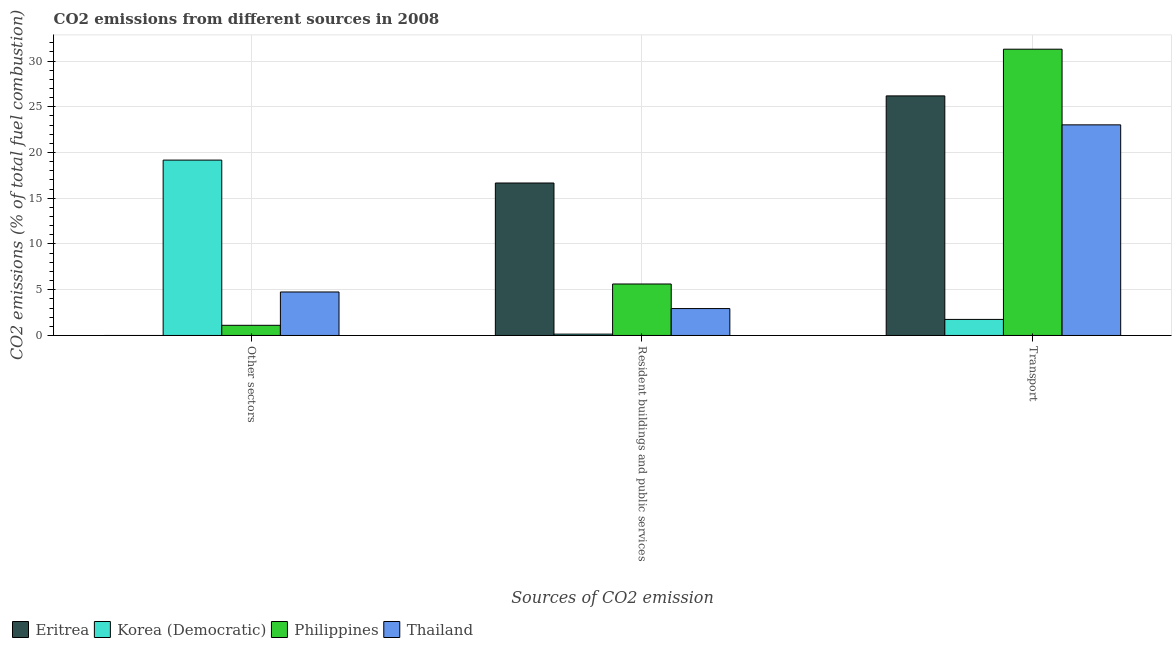How many different coloured bars are there?
Make the answer very short. 4. How many groups of bars are there?
Keep it short and to the point. 3. Are the number of bars per tick equal to the number of legend labels?
Provide a short and direct response. No. How many bars are there on the 1st tick from the right?
Your answer should be very brief. 4. What is the label of the 1st group of bars from the left?
Offer a very short reply. Other sectors. What is the percentage of co2 emissions from other sectors in Philippines?
Your answer should be compact. 1.11. Across all countries, what is the maximum percentage of co2 emissions from other sectors?
Offer a terse response. 19.17. Across all countries, what is the minimum percentage of co2 emissions from resident buildings and public services?
Provide a succinct answer. 0.15. In which country was the percentage of co2 emissions from resident buildings and public services maximum?
Your answer should be compact. Eritrea. What is the total percentage of co2 emissions from transport in the graph?
Your answer should be compact. 82.27. What is the difference between the percentage of co2 emissions from resident buildings and public services in Eritrea and that in Thailand?
Provide a succinct answer. 13.73. What is the difference between the percentage of co2 emissions from other sectors in Korea (Democratic) and the percentage of co2 emissions from resident buildings and public services in Eritrea?
Your response must be concise. 2.5. What is the average percentage of co2 emissions from transport per country?
Provide a short and direct response. 20.57. What is the difference between the percentage of co2 emissions from resident buildings and public services and percentage of co2 emissions from transport in Philippines?
Give a very brief answer. -25.67. What is the ratio of the percentage of co2 emissions from transport in Thailand to that in Philippines?
Provide a short and direct response. 0.74. Is the difference between the percentage of co2 emissions from resident buildings and public services in Philippines and Thailand greater than the difference between the percentage of co2 emissions from other sectors in Philippines and Thailand?
Offer a very short reply. Yes. What is the difference between the highest and the second highest percentage of co2 emissions from resident buildings and public services?
Make the answer very short. 11.04. What is the difference between the highest and the lowest percentage of co2 emissions from resident buildings and public services?
Your response must be concise. 16.52. In how many countries, is the percentage of co2 emissions from resident buildings and public services greater than the average percentage of co2 emissions from resident buildings and public services taken over all countries?
Your answer should be very brief. 1. Is the sum of the percentage of co2 emissions from resident buildings and public services in Philippines and Thailand greater than the maximum percentage of co2 emissions from transport across all countries?
Provide a succinct answer. No. Are all the bars in the graph horizontal?
Provide a succinct answer. No. How many countries are there in the graph?
Your response must be concise. 4. Does the graph contain any zero values?
Ensure brevity in your answer.  Yes. How are the legend labels stacked?
Offer a terse response. Horizontal. What is the title of the graph?
Make the answer very short. CO2 emissions from different sources in 2008. What is the label or title of the X-axis?
Your answer should be very brief. Sources of CO2 emission. What is the label or title of the Y-axis?
Offer a terse response. CO2 emissions (% of total fuel combustion). What is the CO2 emissions (% of total fuel combustion) of Korea (Democratic) in Other sectors?
Offer a very short reply. 19.17. What is the CO2 emissions (% of total fuel combustion) in Philippines in Other sectors?
Your answer should be very brief. 1.11. What is the CO2 emissions (% of total fuel combustion) in Thailand in Other sectors?
Offer a very short reply. 4.75. What is the CO2 emissions (% of total fuel combustion) in Eritrea in Resident buildings and public services?
Give a very brief answer. 16.67. What is the CO2 emissions (% of total fuel combustion) in Korea (Democratic) in Resident buildings and public services?
Offer a very short reply. 0.15. What is the CO2 emissions (% of total fuel combustion) of Philippines in Resident buildings and public services?
Offer a very short reply. 5.63. What is the CO2 emissions (% of total fuel combustion) of Thailand in Resident buildings and public services?
Offer a very short reply. 2.94. What is the CO2 emissions (% of total fuel combustion) of Eritrea in Transport?
Your answer should be very brief. 26.19. What is the CO2 emissions (% of total fuel combustion) of Korea (Democratic) in Transport?
Your answer should be compact. 1.75. What is the CO2 emissions (% of total fuel combustion) of Philippines in Transport?
Offer a terse response. 31.3. What is the CO2 emissions (% of total fuel combustion) of Thailand in Transport?
Provide a short and direct response. 23.02. Across all Sources of CO2 emission, what is the maximum CO2 emissions (% of total fuel combustion) of Eritrea?
Your answer should be compact. 26.19. Across all Sources of CO2 emission, what is the maximum CO2 emissions (% of total fuel combustion) of Korea (Democratic)?
Give a very brief answer. 19.17. Across all Sources of CO2 emission, what is the maximum CO2 emissions (% of total fuel combustion) in Philippines?
Offer a terse response. 31.3. Across all Sources of CO2 emission, what is the maximum CO2 emissions (% of total fuel combustion) of Thailand?
Keep it short and to the point. 23.02. Across all Sources of CO2 emission, what is the minimum CO2 emissions (% of total fuel combustion) of Korea (Democratic)?
Make the answer very short. 0.15. Across all Sources of CO2 emission, what is the minimum CO2 emissions (% of total fuel combustion) of Philippines?
Ensure brevity in your answer.  1.11. Across all Sources of CO2 emission, what is the minimum CO2 emissions (% of total fuel combustion) in Thailand?
Keep it short and to the point. 2.94. What is the total CO2 emissions (% of total fuel combustion) of Eritrea in the graph?
Your answer should be very brief. 42.86. What is the total CO2 emissions (% of total fuel combustion) in Korea (Democratic) in the graph?
Your response must be concise. 21.07. What is the total CO2 emissions (% of total fuel combustion) in Philippines in the graph?
Offer a terse response. 38.03. What is the total CO2 emissions (% of total fuel combustion) in Thailand in the graph?
Offer a terse response. 30.72. What is the difference between the CO2 emissions (% of total fuel combustion) of Korea (Democratic) in Other sectors and that in Resident buildings and public services?
Give a very brief answer. 19.03. What is the difference between the CO2 emissions (% of total fuel combustion) in Philippines in Other sectors and that in Resident buildings and public services?
Provide a short and direct response. -4.52. What is the difference between the CO2 emissions (% of total fuel combustion) in Thailand in Other sectors and that in Resident buildings and public services?
Ensure brevity in your answer.  1.81. What is the difference between the CO2 emissions (% of total fuel combustion) in Korea (Democratic) in Other sectors and that in Transport?
Your response must be concise. 17.42. What is the difference between the CO2 emissions (% of total fuel combustion) in Philippines in Other sectors and that in Transport?
Keep it short and to the point. -30.19. What is the difference between the CO2 emissions (% of total fuel combustion) in Thailand in Other sectors and that in Transport?
Your response must be concise. -18.27. What is the difference between the CO2 emissions (% of total fuel combustion) in Eritrea in Resident buildings and public services and that in Transport?
Offer a very short reply. -9.52. What is the difference between the CO2 emissions (% of total fuel combustion) in Korea (Democratic) in Resident buildings and public services and that in Transport?
Provide a short and direct response. -1.61. What is the difference between the CO2 emissions (% of total fuel combustion) in Philippines in Resident buildings and public services and that in Transport?
Offer a terse response. -25.67. What is the difference between the CO2 emissions (% of total fuel combustion) of Thailand in Resident buildings and public services and that in Transport?
Provide a short and direct response. -20.08. What is the difference between the CO2 emissions (% of total fuel combustion) in Korea (Democratic) in Other sectors and the CO2 emissions (% of total fuel combustion) in Philippines in Resident buildings and public services?
Ensure brevity in your answer.  13.54. What is the difference between the CO2 emissions (% of total fuel combustion) of Korea (Democratic) in Other sectors and the CO2 emissions (% of total fuel combustion) of Thailand in Resident buildings and public services?
Your response must be concise. 16.23. What is the difference between the CO2 emissions (% of total fuel combustion) of Philippines in Other sectors and the CO2 emissions (% of total fuel combustion) of Thailand in Resident buildings and public services?
Make the answer very short. -1.83. What is the difference between the CO2 emissions (% of total fuel combustion) of Korea (Democratic) in Other sectors and the CO2 emissions (% of total fuel combustion) of Philippines in Transport?
Your answer should be very brief. -12.13. What is the difference between the CO2 emissions (% of total fuel combustion) in Korea (Democratic) in Other sectors and the CO2 emissions (% of total fuel combustion) in Thailand in Transport?
Ensure brevity in your answer.  -3.85. What is the difference between the CO2 emissions (% of total fuel combustion) of Philippines in Other sectors and the CO2 emissions (% of total fuel combustion) of Thailand in Transport?
Your answer should be very brief. -21.91. What is the difference between the CO2 emissions (% of total fuel combustion) in Eritrea in Resident buildings and public services and the CO2 emissions (% of total fuel combustion) in Korea (Democratic) in Transport?
Ensure brevity in your answer.  14.91. What is the difference between the CO2 emissions (% of total fuel combustion) in Eritrea in Resident buildings and public services and the CO2 emissions (% of total fuel combustion) in Philippines in Transport?
Your answer should be compact. -14.63. What is the difference between the CO2 emissions (% of total fuel combustion) in Eritrea in Resident buildings and public services and the CO2 emissions (% of total fuel combustion) in Thailand in Transport?
Ensure brevity in your answer.  -6.36. What is the difference between the CO2 emissions (% of total fuel combustion) in Korea (Democratic) in Resident buildings and public services and the CO2 emissions (% of total fuel combustion) in Philippines in Transport?
Your response must be concise. -31.15. What is the difference between the CO2 emissions (% of total fuel combustion) of Korea (Democratic) in Resident buildings and public services and the CO2 emissions (% of total fuel combustion) of Thailand in Transport?
Ensure brevity in your answer.  -22.88. What is the difference between the CO2 emissions (% of total fuel combustion) of Philippines in Resident buildings and public services and the CO2 emissions (% of total fuel combustion) of Thailand in Transport?
Give a very brief answer. -17.4. What is the average CO2 emissions (% of total fuel combustion) in Eritrea per Sources of CO2 emission?
Give a very brief answer. 14.29. What is the average CO2 emissions (% of total fuel combustion) of Korea (Democratic) per Sources of CO2 emission?
Provide a succinct answer. 7.02. What is the average CO2 emissions (% of total fuel combustion) in Philippines per Sources of CO2 emission?
Your answer should be compact. 12.68. What is the average CO2 emissions (% of total fuel combustion) of Thailand per Sources of CO2 emission?
Make the answer very short. 10.24. What is the difference between the CO2 emissions (% of total fuel combustion) of Korea (Democratic) and CO2 emissions (% of total fuel combustion) of Philippines in Other sectors?
Keep it short and to the point. 18.06. What is the difference between the CO2 emissions (% of total fuel combustion) of Korea (Democratic) and CO2 emissions (% of total fuel combustion) of Thailand in Other sectors?
Give a very brief answer. 14.42. What is the difference between the CO2 emissions (% of total fuel combustion) in Philippines and CO2 emissions (% of total fuel combustion) in Thailand in Other sectors?
Ensure brevity in your answer.  -3.64. What is the difference between the CO2 emissions (% of total fuel combustion) in Eritrea and CO2 emissions (% of total fuel combustion) in Korea (Democratic) in Resident buildings and public services?
Keep it short and to the point. 16.52. What is the difference between the CO2 emissions (% of total fuel combustion) of Eritrea and CO2 emissions (% of total fuel combustion) of Philippines in Resident buildings and public services?
Make the answer very short. 11.04. What is the difference between the CO2 emissions (% of total fuel combustion) in Eritrea and CO2 emissions (% of total fuel combustion) in Thailand in Resident buildings and public services?
Keep it short and to the point. 13.73. What is the difference between the CO2 emissions (% of total fuel combustion) in Korea (Democratic) and CO2 emissions (% of total fuel combustion) in Philippines in Resident buildings and public services?
Give a very brief answer. -5.48. What is the difference between the CO2 emissions (% of total fuel combustion) in Korea (Democratic) and CO2 emissions (% of total fuel combustion) in Thailand in Resident buildings and public services?
Provide a short and direct response. -2.8. What is the difference between the CO2 emissions (% of total fuel combustion) of Philippines and CO2 emissions (% of total fuel combustion) of Thailand in Resident buildings and public services?
Your answer should be compact. 2.69. What is the difference between the CO2 emissions (% of total fuel combustion) in Eritrea and CO2 emissions (% of total fuel combustion) in Korea (Democratic) in Transport?
Ensure brevity in your answer.  24.44. What is the difference between the CO2 emissions (% of total fuel combustion) of Eritrea and CO2 emissions (% of total fuel combustion) of Philippines in Transport?
Make the answer very short. -5.11. What is the difference between the CO2 emissions (% of total fuel combustion) of Eritrea and CO2 emissions (% of total fuel combustion) of Thailand in Transport?
Make the answer very short. 3.17. What is the difference between the CO2 emissions (% of total fuel combustion) in Korea (Democratic) and CO2 emissions (% of total fuel combustion) in Philippines in Transport?
Make the answer very short. -29.54. What is the difference between the CO2 emissions (% of total fuel combustion) in Korea (Democratic) and CO2 emissions (% of total fuel combustion) in Thailand in Transport?
Your response must be concise. -21.27. What is the difference between the CO2 emissions (% of total fuel combustion) in Philippines and CO2 emissions (% of total fuel combustion) in Thailand in Transport?
Give a very brief answer. 8.27. What is the ratio of the CO2 emissions (% of total fuel combustion) of Korea (Democratic) in Other sectors to that in Resident buildings and public services?
Keep it short and to the point. 132.2. What is the ratio of the CO2 emissions (% of total fuel combustion) of Philippines in Other sectors to that in Resident buildings and public services?
Your answer should be compact. 0.2. What is the ratio of the CO2 emissions (% of total fuel combustion) in Thailand in Other sectors to that in Resident buildings and public services?
Make the answer very short. 1.62. What is the ratio of the CO2 emissions (% of total fuel combustion) of Korea (Democratic) in Other sectors to that in Transport?
Provide a succinct answer. 10.93. What is the ratio of the CO2 emissions (% of total fuel combustion) of Philippines in Other sectors to that in Transport?
Offer a very short reply. 0.04. What is the ratio of the CO2 emissions (% of total fuel combustion) in Thailand in Other sectors to that in Transport?
Your answer should be very brief. 0.21. What is the ratio of the CO2 emissions (% of total fuel combustion) of Eritrea in Resident buildings and public services to that in Transport?
Your answer should be very brief. 0.64. What is the ratio of the CO2 emissions (% of total fuel combustion) in Korea (Democratic) in Resident buildings and public services to that in Transport?
Your response must be concise. 0.08. What is the ratio of the CO2 emissions (% of total fuel combustion) of Philippines in Resident buildings and public services to that in Transport?
Give a very brief answer. 0.18. What is the ratio of the CO2 emissions (% of total fuel combustion) of Thailand in Resident buildings and public services to that in Transport?
Your answer should be compact. 0.13. What is the difference between the highest and the second highest CO2 emissions (% of total fuel combustion) of Korea (Democratic)?
Your response must be concise. 17.42. What is the difference between the highest and the second highest CO2 emissions (% of total fuel combustion) in Philippines?
Ensure brevity in your answer.  25.67. What is the difference between the highest and the second highest CO2 emissions (% of total fuel combustion) in Thailand?
Keep it short and to the point. 18.27. What is the difference between the highest and the lowest CO2 emissions (% of total fuel combustion) in Eritrea?
Give a very brief answer. 26.19. What is the difference between the highest and the lowest CO2 emissions (% of total fuel combustion) of Korea (Democratic)?
Offer a very short reply. 19.03. What is the difference between the highest and the lowest CO2 emissions (% of total fuel combustion) of Philippines?
Your answer should be very brief. 30.19. What is the difference between the highest and the lowest CO2 emissions (% of total fuel combustion) of Thailand?
Make the answer very short. 20.08. 